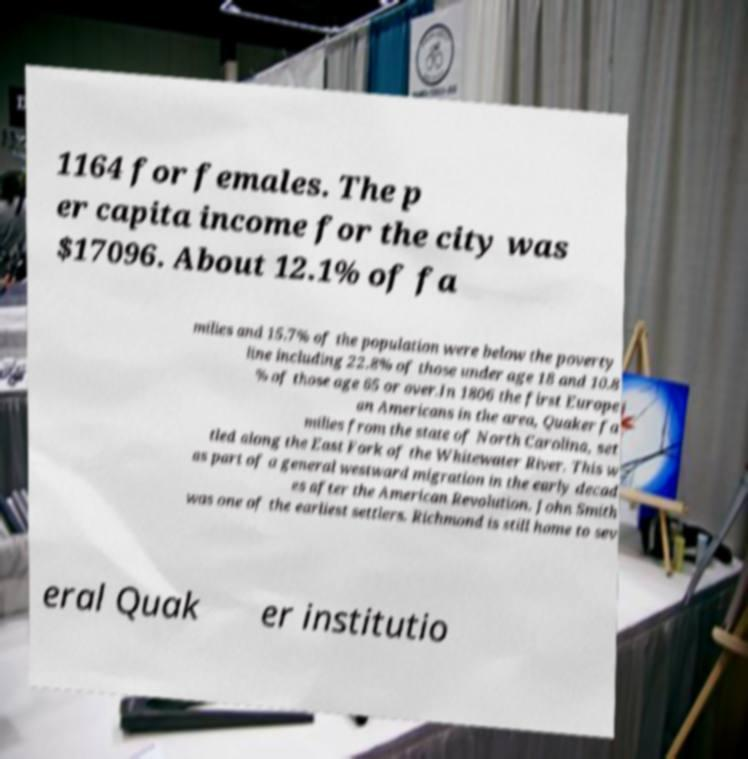Could you assist in decoding the text presented in this image and type it out clearly? 1164 for females. The p er capita income for the city was $17096. About 12.1% of fa milies and 15.7% of the population were below the poverty line including 22.8% of those under age 18 and 10.8 % of those age 65 or over.In 1806 the first Europe an Americans in the area, Quaker fa milies from the state of North Carolina, set tled along the East Fork of the Whitewater River. This w as part of a general westward migration in the early decad es after the American Revolution. John Smith was one of the earliest settlers. Richmond is still home to sev eral Quak er institutio 